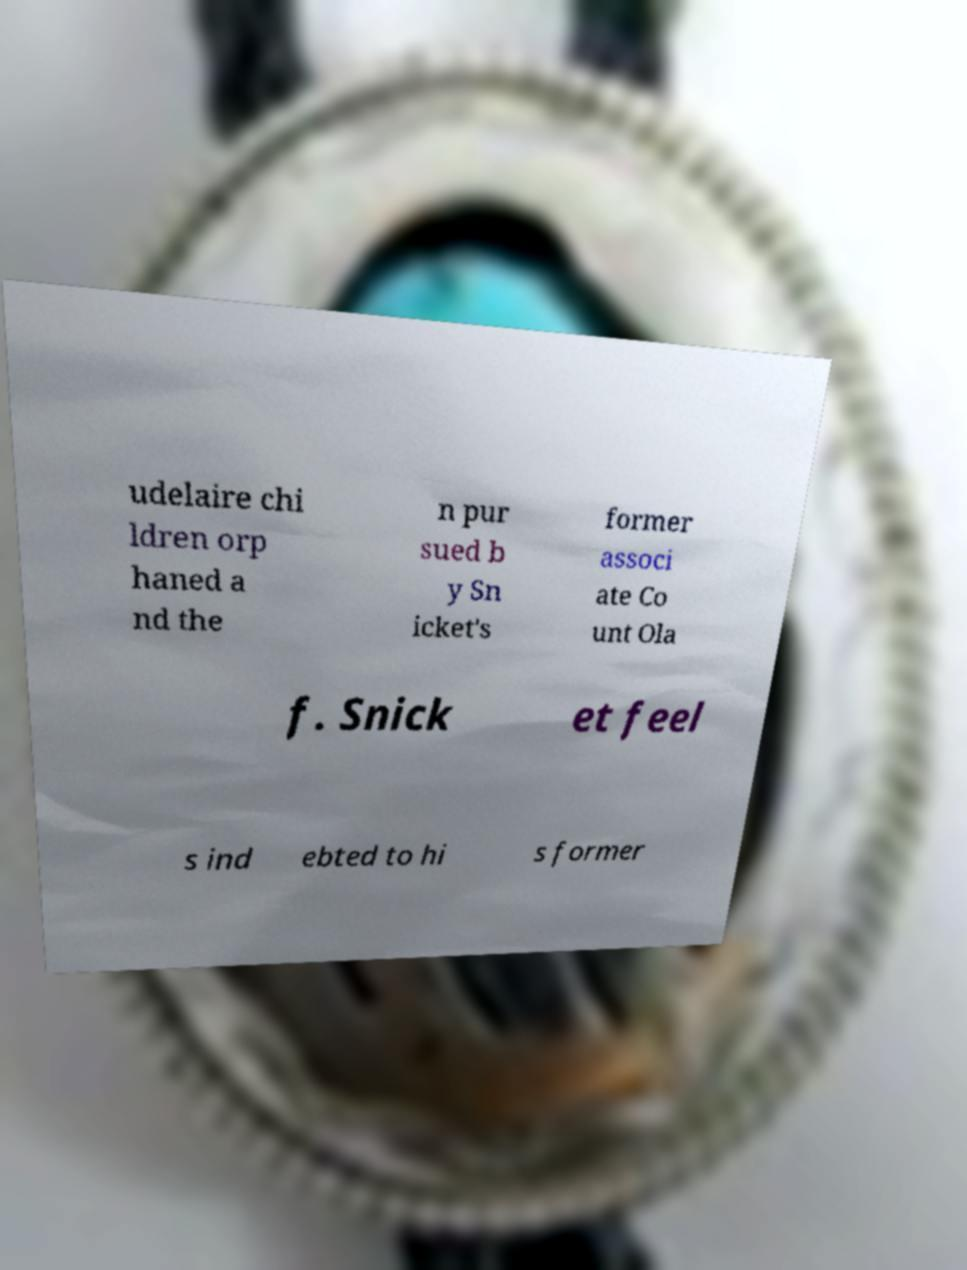What messages or text are displayed in this image? I need them in a readable, typed format. udelaire chi ldren orp haned a nd the n pur sued b y Sn icket's former associ ate Co unt Ola f. Snick et feel s ind ebted to hi s former 